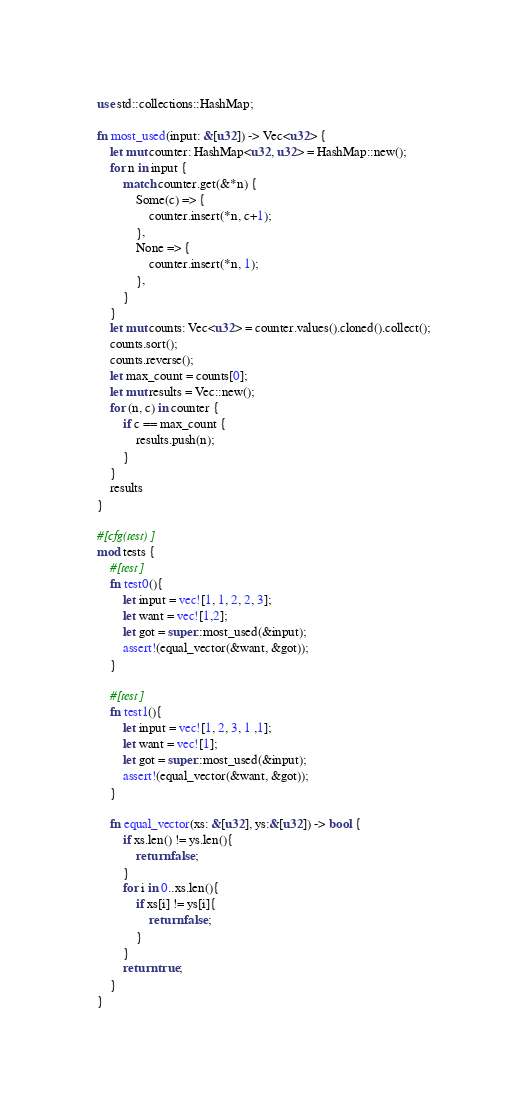<code> <loc_0><loc_0><loc_500><loc_500><_Rust_>use std::collections::HashMap;

fn most_used(input: &[u32]) -> Vec<u32> {
    let mut counter: HashMap<u32, u32> = HashMap::new();
    for n in input {
        match counter.get(&*n) {
            Some(c) => {
                counter.insert(*n, c+1);
            },
            None => {
                counter.insert(*n, 1);
            },
        }
    }
    let mut counts: Vec<u32> = counter.values().cloned().collect();
    counts.sort();
    counts.reverse();
    let max_count = counts[0];
    let mut results = Vec::new();
    for (n, c) in counter {
        if c == max_count {
            results.push(n);
        }
    }
    results
}

#[cfg(test)]
mod tests {
    #[test]
    fn test0(){
        let input = vec![1, 1, 2, 2, 3];
        let want = vec![1,2];
        let got = super::most_used(&input);
        assert!(equal_vector(&want, &got));
    }

    #[test]
    fn test1(){
        let input = vec![1, 2, 3, 1 ,1];
        let want = vec![1];
        let got = super::most_used(&input);
        assert!(equal_vector(&want, &got));
    }

    fn equal_vector(xs: &[u32], ys:&[u32]) -> bool {
        if xs.len() != ys.len(){
            return false;
        }
        for i in 0..xs.len(){
            if xs[i] != ys[i]{
                return false;
            }
        }
        return true;
    }
}</code> 